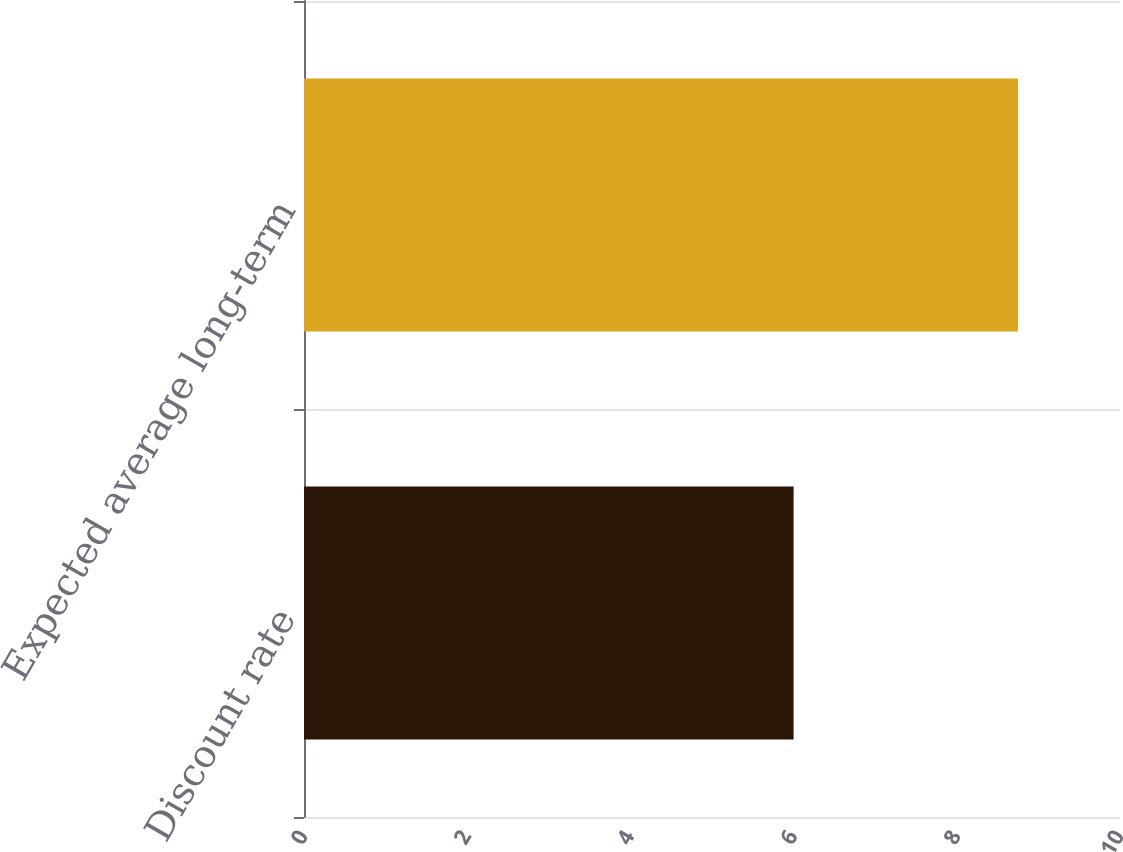<chart> <loc_0><loc_0><loc_500><loc_500><bar_chart><fcel>Discount rate<fcel>Expected average long-term<nl><fcel>6<fcel>8.75<nl></chart> 